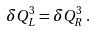Convert formula to latex. <formula><loc_0><loc_0><loc_500><loc_500>\delta Q ^ { 3 } _ { L } = \delta Q ^ { 3 } _ { R } \, .</formula> 